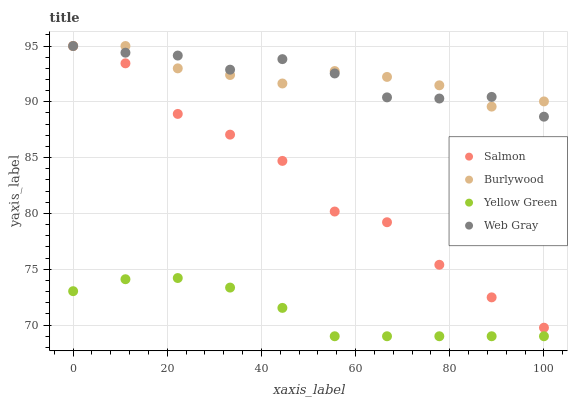Does Yellow Green have the minimum area under the curve?
Answer yes or no. Yes. Does Web Gray have the maximum area under the curve?
Answer yes or no. Yes. Does Salmon have the minimum area under the curve?
Answer yes or no. No. Does Salmon have the maximum area under the curve?
Answer yes or no. No. Is Yellow Green the smoothest?
Answer yes or no. Yes. Is Salmon the roughest?
Answer yes or no. Yes. Is Web Gray the smoothest?
Answer yes or no. No. Is Web Gray the roughest?
Answer yes or no. No. Does Yellow Green have the lowest value?
Answer yes or no. Yes. Does Web Gray have the lowest value?
Answer yes or no. No. Does Salmon have the highest value?
Answer yes or no. Yes. Does Yellow Green have the highest value?
Answer yes or no. No. Is Yellow Green less than Salmon?
Answer yes or no. Yes. Is Burlywood greater than Yellow Green?
Answer yes or no. Yes. Does Burlywood intersect Web Gray?
Answer yes or no. Yes. Is Burlywood less than Web Gray?
Answer yes or no. No. Is Burlywood greater than Web Gray?
Answer yes or no. No. Does Yellow Green intersect Salmon?
Answer yes or no. No. 